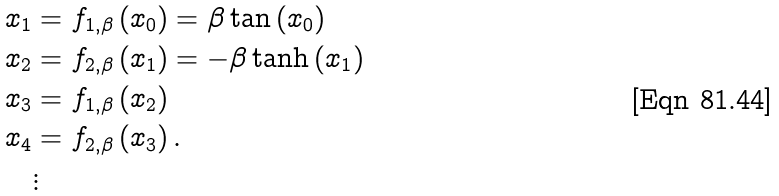<formula> <loc_0><loc_0><loc_500><loc_500>x _ { 1 } & = f _ { 1 , \beta } \left ( x _ { 0 } \right ) = \beta \tan \left ( x _ { 0 } \right ) \\ x _ { 2 } & = f _ { 2 , \beta } \left ( x _ { 1 } \right ) = - \beta \tanh \left ( x _ { 1 } \right ) \\ x _ { 3 } & = f _ { 1 , \beta } \left ( x _ { 2 } \right ) \\ x _ { 4 } & = f _ { 2 , \beta } \left ( x _ { 3 } \right ) . \\ & \vdots</formula> 